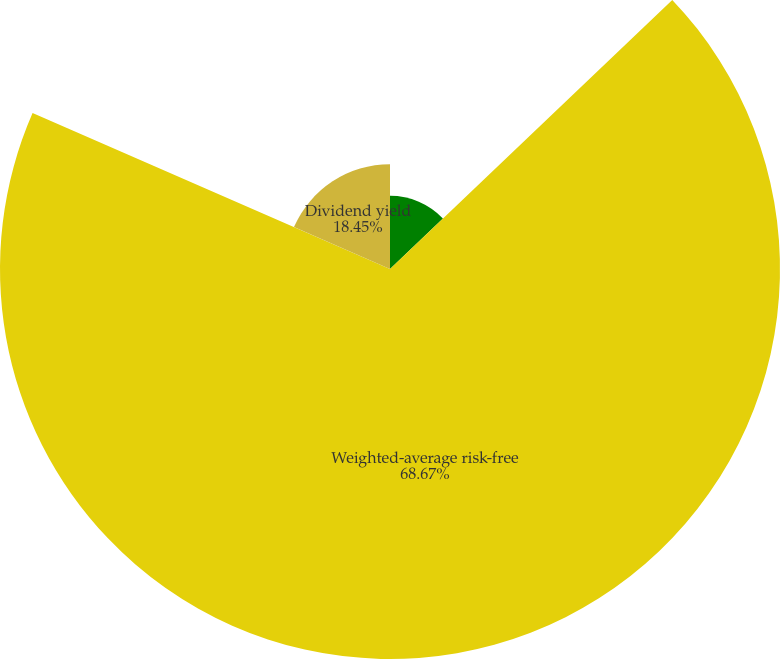Convert chart. <chart><loc_0><loc_0><loc_500><loc_500><pie_chart><fcel>Volatility<fcel>Weighted-average risk-free<fcel>Dividend yield<nl><fcel>12.88%<fcel>68.67%<fcel>18.45%<nl></chart> 